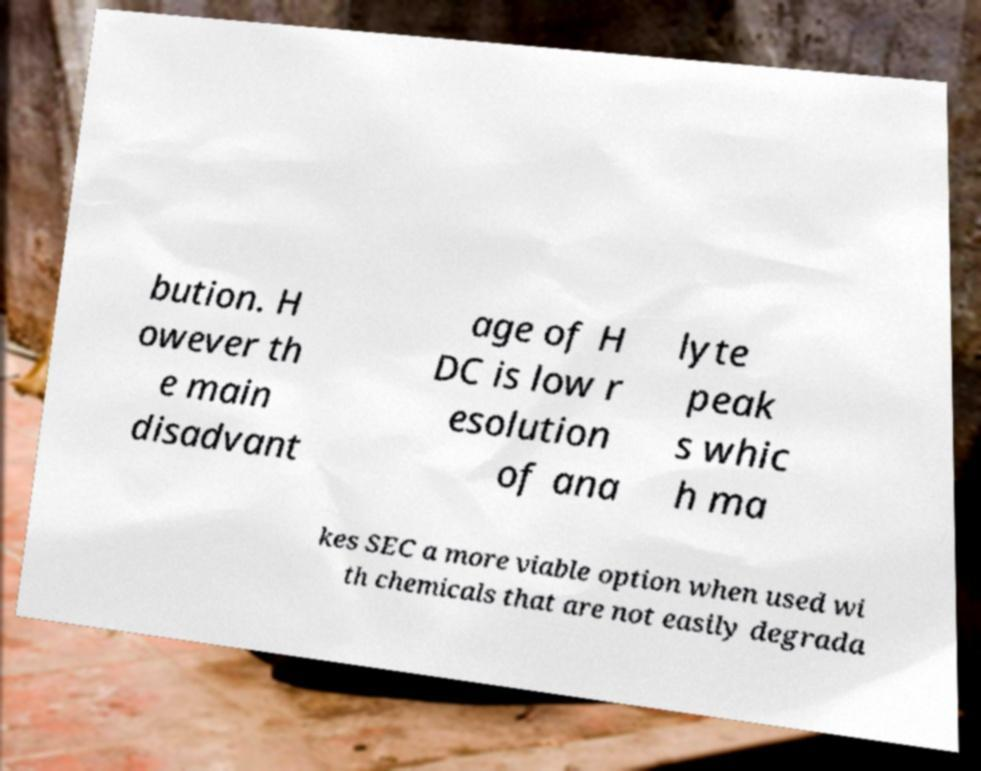Can you read and provide the text displayed in the image?This photo seems to have some interesting text. Can you extract and type it out for me? bution. H owever th e main disadvant age of H DC is low r esolution of ana lyte peak s whic h ma kes SEC a more viable option when used wi th chemicals that are not easily degrada 